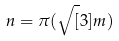Convert formula to latex. <formula><loc_0><loc_0><loc_500><loc_500>n = \pi ( \sqrt { [ } 3 ] { m } )</formula> 